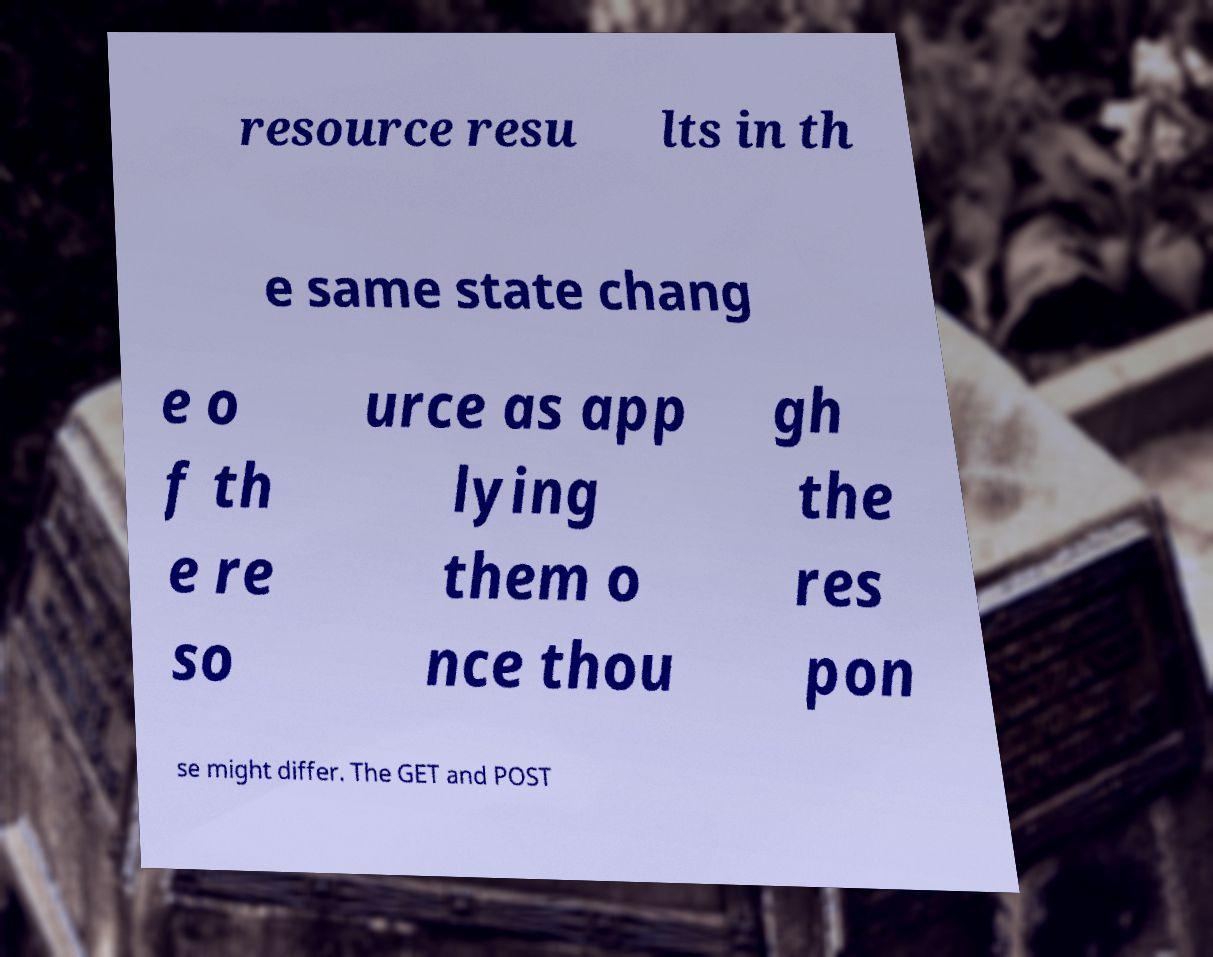Could you assist in decoding the text presented in this image and type it out clearly? resource resu lts in th e same state chang e o f th e re so urce as app lying them o nce thou gh the res pon se might differ. The GET and POST 